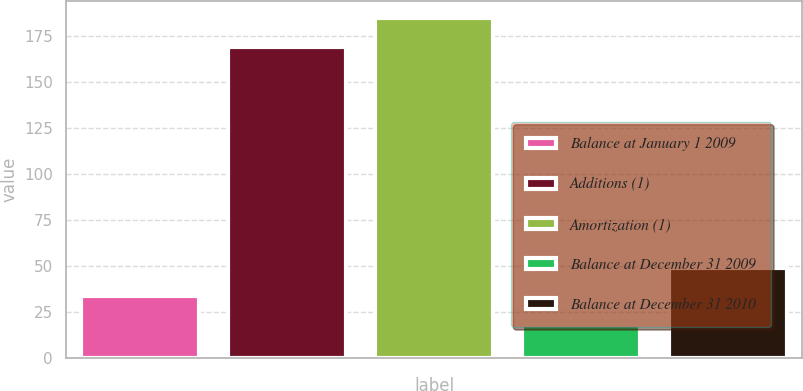Convert chart to OTSL. <chart><loc_0><loc_0><loc_500><loc_500><bar_chart><fcel>Balance at January 1 2009<fcel>Additions (1)<fcel>Amortization (1)<fcel>Balance at December 31 2009<fcel>Balance at December 31 2010<nl><fcel>33.5<fcel>169<fcel>184.5<fcel>18<fcel>49<nl></chart> 